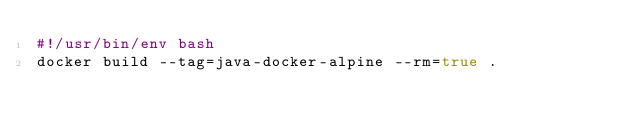Convert code to text. <code><loc_0><loc_0><loc_500><loc_500><_Bash_>#!/usr/bin/env bash
docker build --tag=java-docker-alpine --rm=true .</code> 